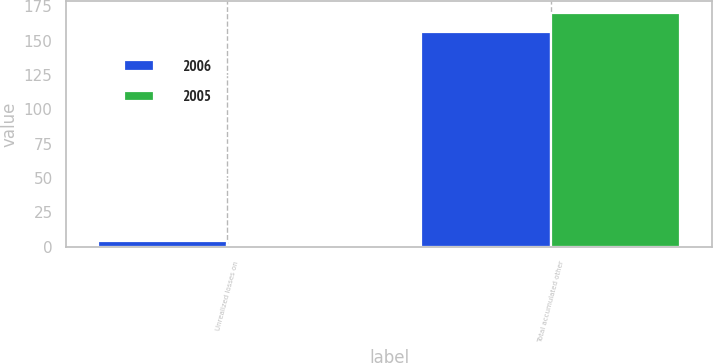<chart> <loc_0><loc_0><loc_500><loc_500><stacked_bar_chart><ecel><fcel>Unrealized losses on<fcel>Total accumulated other<nl><fcel>2006<fcel>4<fcel>156<nl><fcel>2005<fcel>1<fcel>170<nl></chart> 